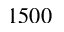Convert formula to latex. <formula><loc_0><loc_0><loc_500><loc_500>1 5 0 0</formula> 